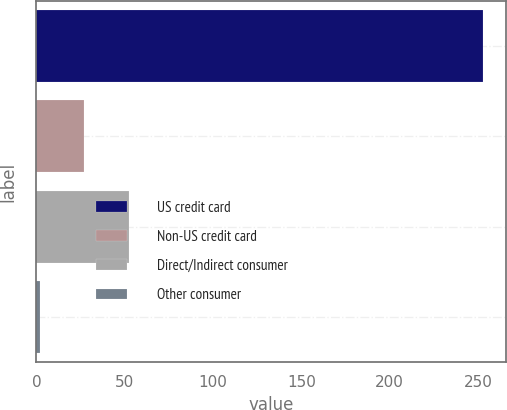Convert chart. <chart><loc_0><loc_0><loc_500><loc_500><bar_chart><fcel>US credit card<fcel>Non-US credit card<fcel>Direct/Indirect consumer<fcel>Other consumer<nl><fcel>253<fcel>27.1<fcel>52.2<fcel>2<nl></chart> 